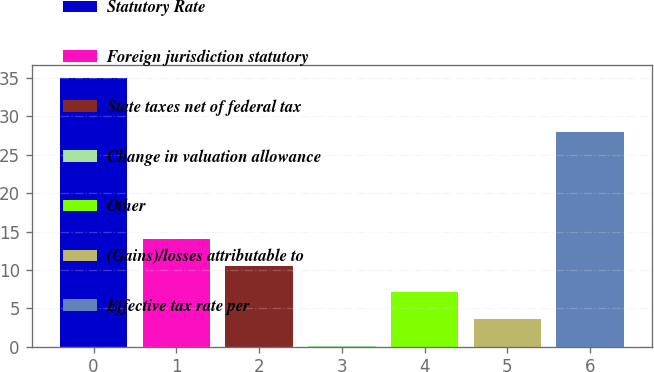Convert chart to OTSL. <chart><loc_0><loc_0><loc_500><loc_500><bar_chart><fcel>Statutory Rate<fcel>Foreign jurisdiction statutory<fcel>State taxes net of federal tax<fcel>Change in valuation allowance<fcel>Other<fcel>(Gains)/losses attributable to<fcel>Effective tax rate per<nl><fcel>35<fcel>14.06<fcel>10.57<fcel>0.1<fcel>7.08<fcel>3.59<fcel>28<nl></chart> 